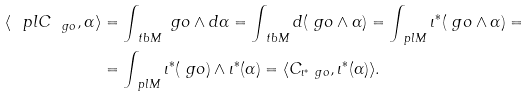Convert formula to latex. <formula><loc_0><loc_0><loc_500><loc_500>\langle \ p l C _ { \ g o } , \alpha \rangle & = \int _ { \ t b M } \ g o \wedge d \alpha = \int _ { \ t b M } d ( \ g o \wedge \alpha ) = \int _ { \ p l M } \iota ^ { * } ( \ g o \wedge \alpha ) = \\ & = \int _ { \ p l M } \iota ^ { * } ( \ g o ) \wedge \iota ^ { * } ( \alpha ) = \langle C _ { \iota ^ { * } \ g o } , \iota ^ { * } ( \alpha ) \rangle .</formula> 